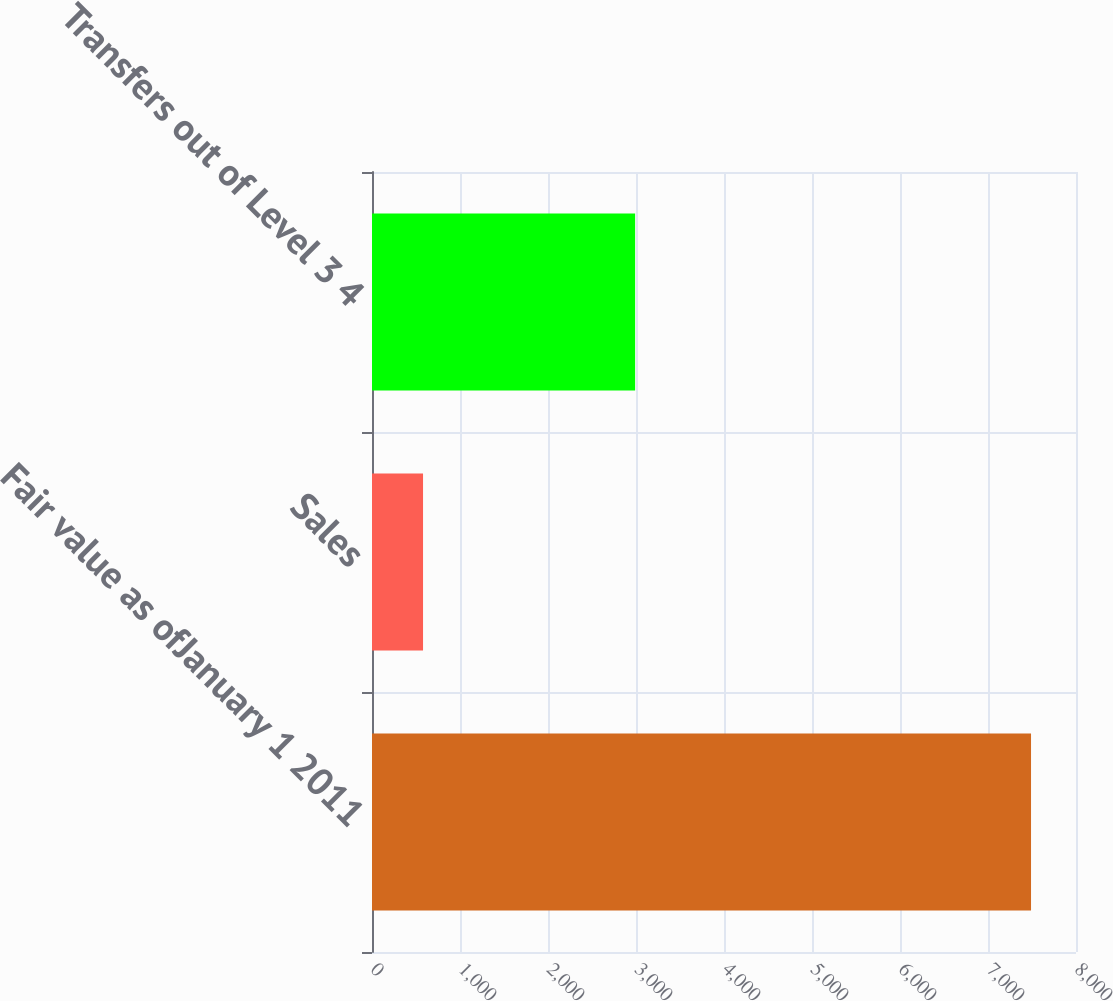Convert chart to OTSL. <chart><loc_0><loc_0><loc_500><loc_500><bar_chart><fcel>Fair value as ofJanuary 1 2011<fcel>Sales<fcel>Transfers out of Level 3 4<nl><fcel>7489<fcel>580<fcel>2990<nl></chart> 